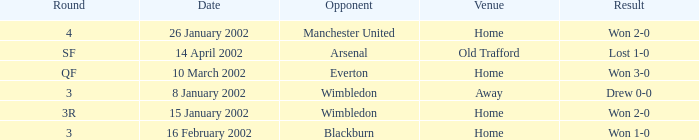What is the Round with a Opponent with blackburn? 3.0. 